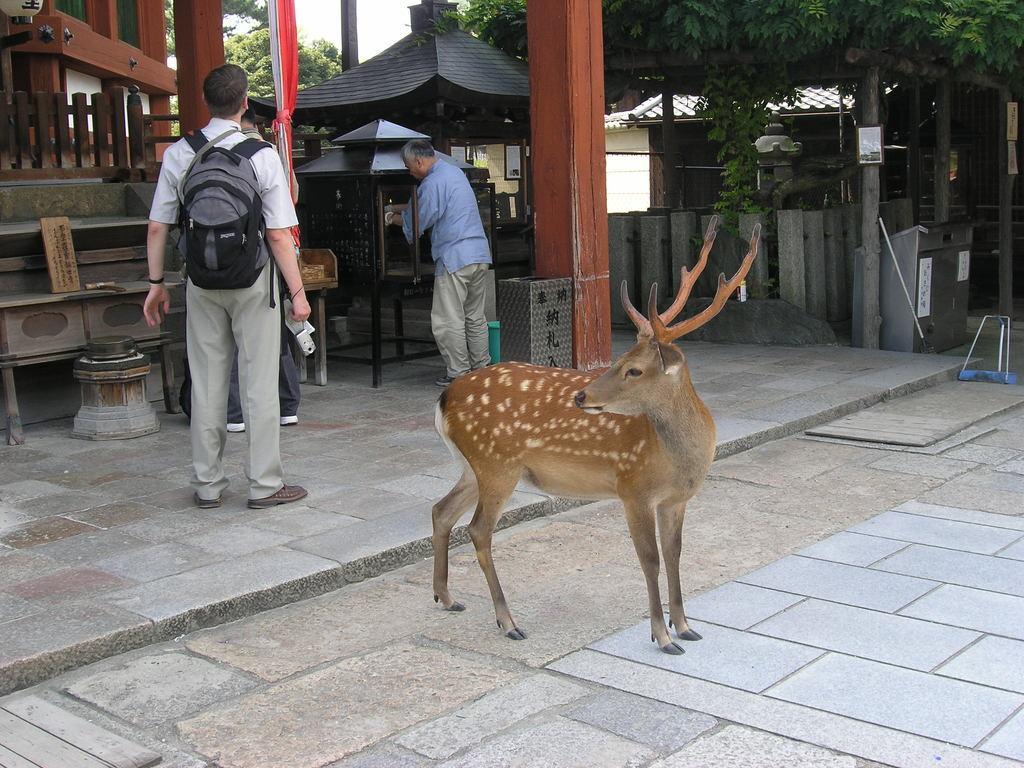How would you summarize this image in a sentence or two? This image is taken outdoors. At the bottom of the image there is a floor. In the middle of the image there is a deer and a man is standing on the floor. In the background there is a house, a fencing and a man is standing on the ground and there are a few wooden sticks and a table on the floor. There are a few trees. 